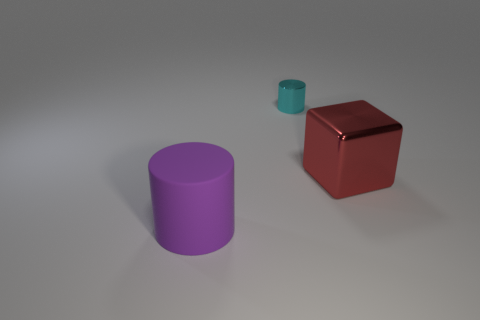Add 2 big gray metallic cylinders. How many objects exist? 5 Subtract all blocks. How many objects are left? 2 Add 2 tiny cyan metallic cylinders. How many tiny cyan metallic cylinders are left? 3 Add 3 small cylinders. How many small cylinders exist? 4 Subtract 0 gray balls. How many objects are left? 3 Subtract all green cylinders. Subtract all yellow cubes. How many cylinders are left? 2 Subtract all gray cubes. How many gray cylinders are left? 0 Subtract all big cylinders. Subtract all big blocks. How many objects are left? 1 